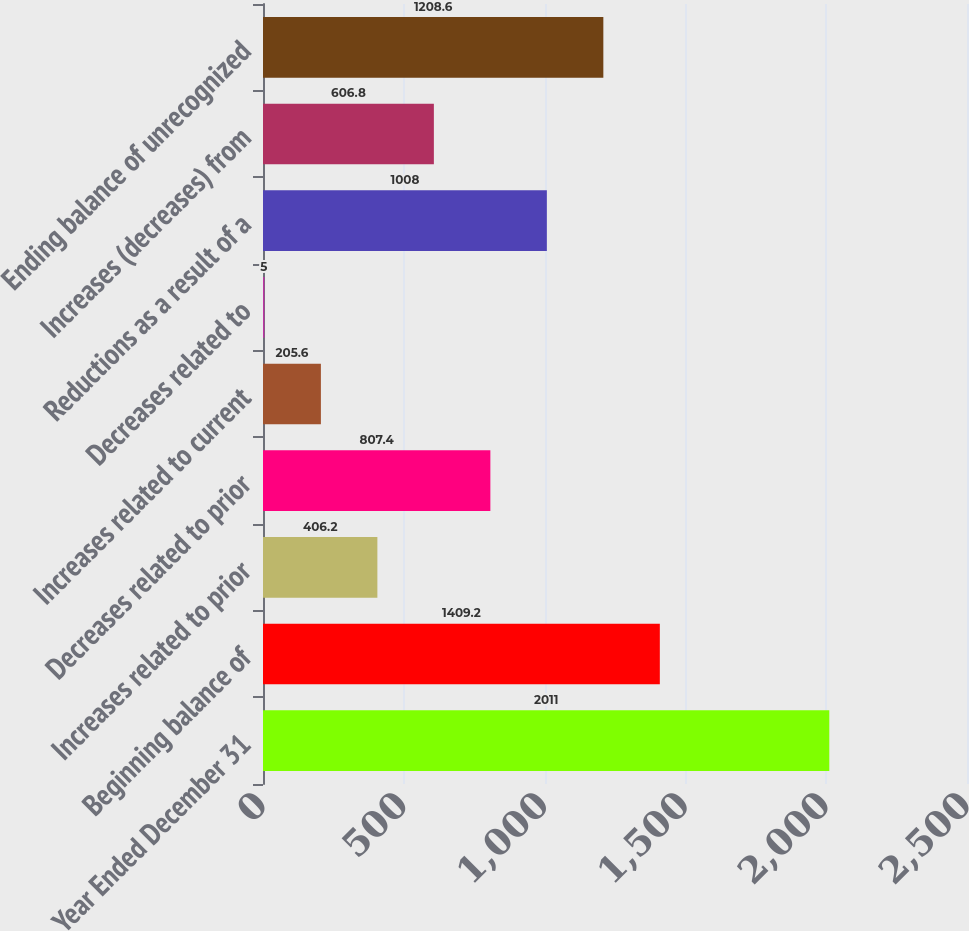Convert chart. <chart><loc_0><loc_0><loc_500><loc_500><bar_chart><fcel>Year Ended December 31<fcel>Beginning balance of<fcel>Increases related to prior<fcel>Decreases related to prior<fcel>Increases related to current<fcel>Decreases related to<fcel>Reductions as a result of a<fcel>Increases (decreases) from<fcel>Ending balance of unrecognized<nl><fcel>2011<fcel>1409.2<fcel>406.2<fcel>807.4<fcel>205.6<fcel>5<fcel>1008<fcel>606.8<fcel>1208.6<nl></chart> 